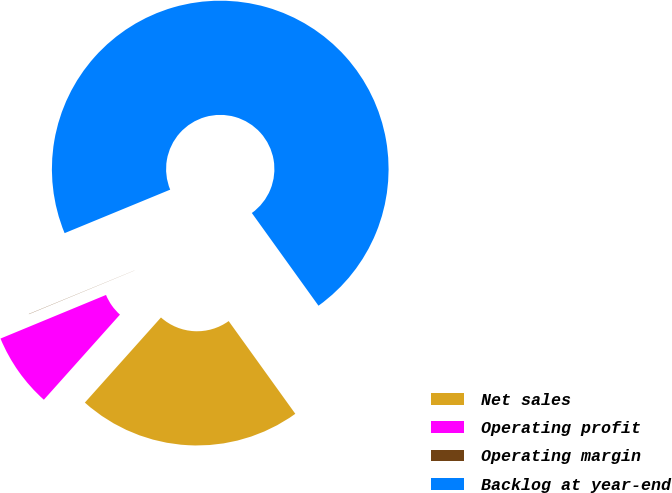Convert chart to OTSL. <chart><loc_0><loc_0><loc_500><loc_500><pie_chart><fcel>Net sales<fcel>Operating profit<fcel>Operating margin<fcel>Backlog at year-end<nl><fcel>21.53%<fcel>7.15%<fcel>0.02%<fcel>71.3%<nl></chart> 